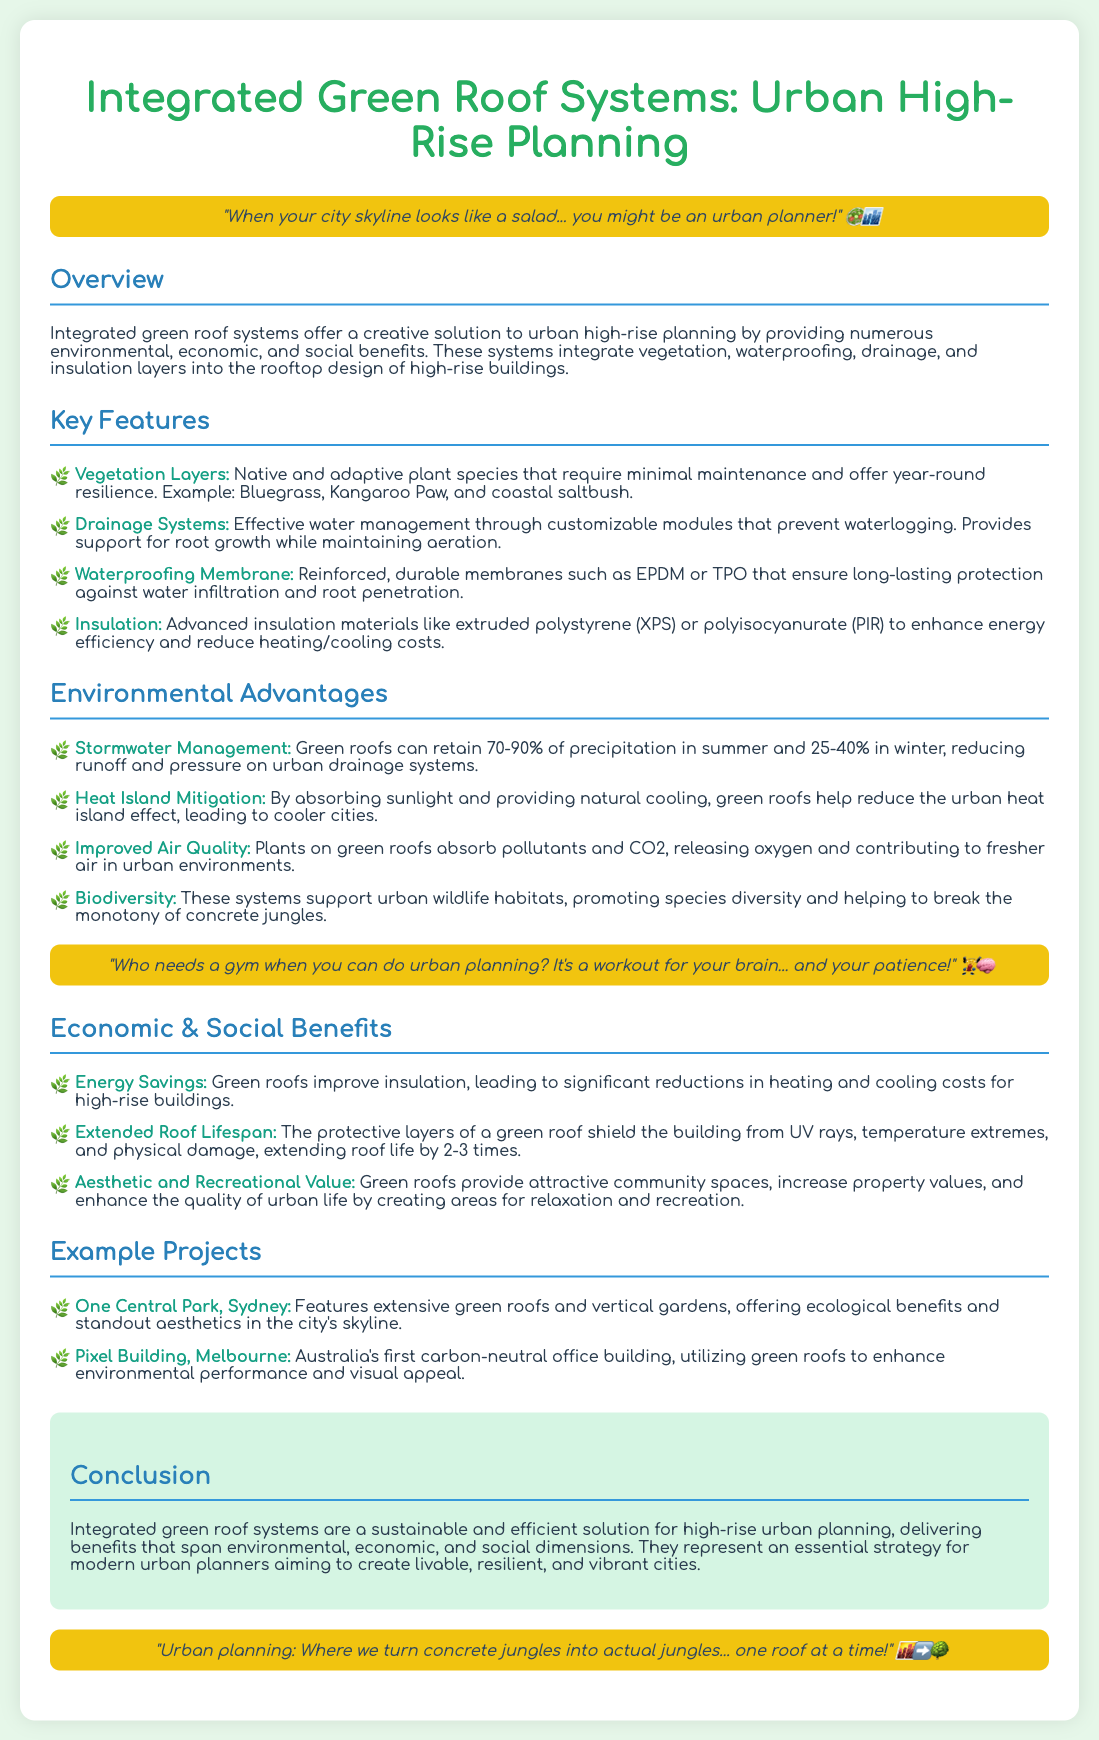What are the vegetation layers? The vegetation layers include native and adaptive plant species that require minimal maintenance and offer year-round resilience. Examples given are Bluegrass, Kangaroo Paw, and coastal saltbush.
Answer: Native and adaptive plant species What percentage of precipitation can green roofs retain in summer? Green roofs can retain 70-90% of precipitation in summer, as stated in the environmental advantages section.
Answer: 70-90% What is one of the insulation materials mentioned? The document lists advanced insulation materials like extruded polystyrene (XPS) or polyisocyanurate (PIR) for enhancing energy efficiency.
Answer: Extruded polystyrene (XPS) Which project features extensive green roofs and vertical gardens? The project mentioned is One Central Park, Sydney, known for its ecological benefits and standout aesthetics.
Answer: One Central Park, Sydney How much longer can a green roof extend the lifespan of a roof? The protective layers of a green roof can extend the roof life by 2-3 times, as noted in the economic and social benefits section.
Answer: 2-3 times What is one environmental advantage of green roofs? One environmental advantage is improved air quality, as plants absorb pollutants and CO2, releasing oxygen.
Answer: Improved air quality What unique feature is found in Pixel Building? Pixel Building is recognized as Australia's first carbon-neutral office building, utilizing green roofs.
Answer: Carbon-neutral office building What humorous meme is included in the document? The document contains a humorous meme about urban planning, stating, "When your city skyline looks like a salad... you might be an urban planner!"
Answer: When your city skyline looks like a salad... you might be an urban planner! 